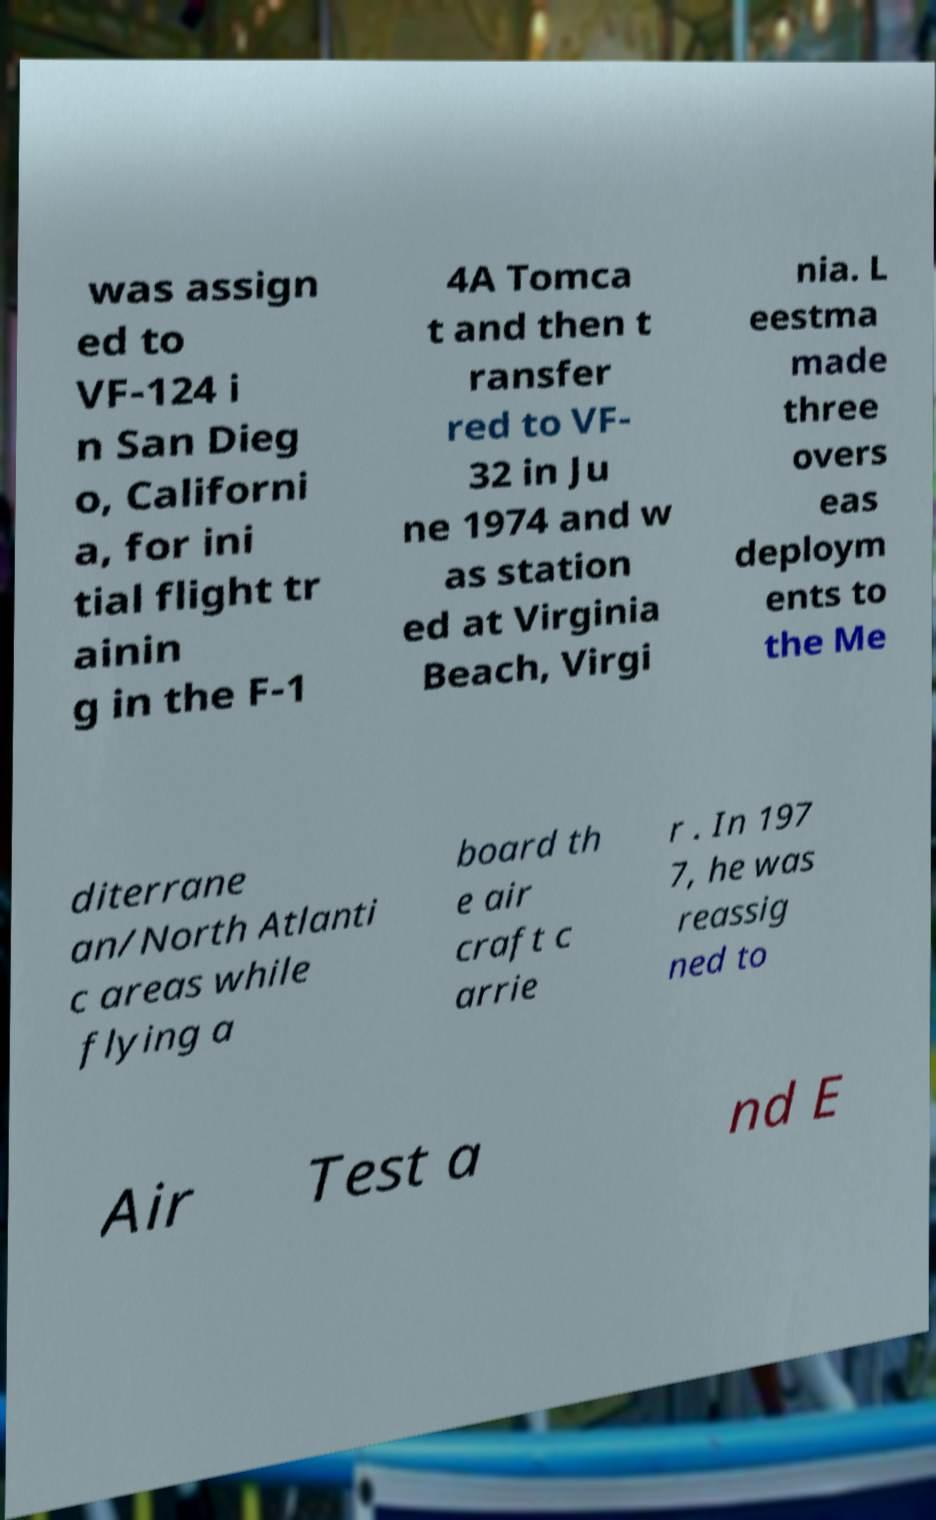Could you extract and type out the text from this image? was assign ed to VF-124 i n San Dieg o, Californi a, for ini tial flight tr ainin g in the F-1 4A Tomca t and then t ransfer red to VF- 32 in Ju ne 1974 and w as station ed at Virginia Beach, Virgi nia. L eestma made three overs eas deploym ents to the Me diterrane an/North Atlanti c areas while flying a board th e air craft c arrie r . In 197 7, he was reassig ned to Air Test a nd E 